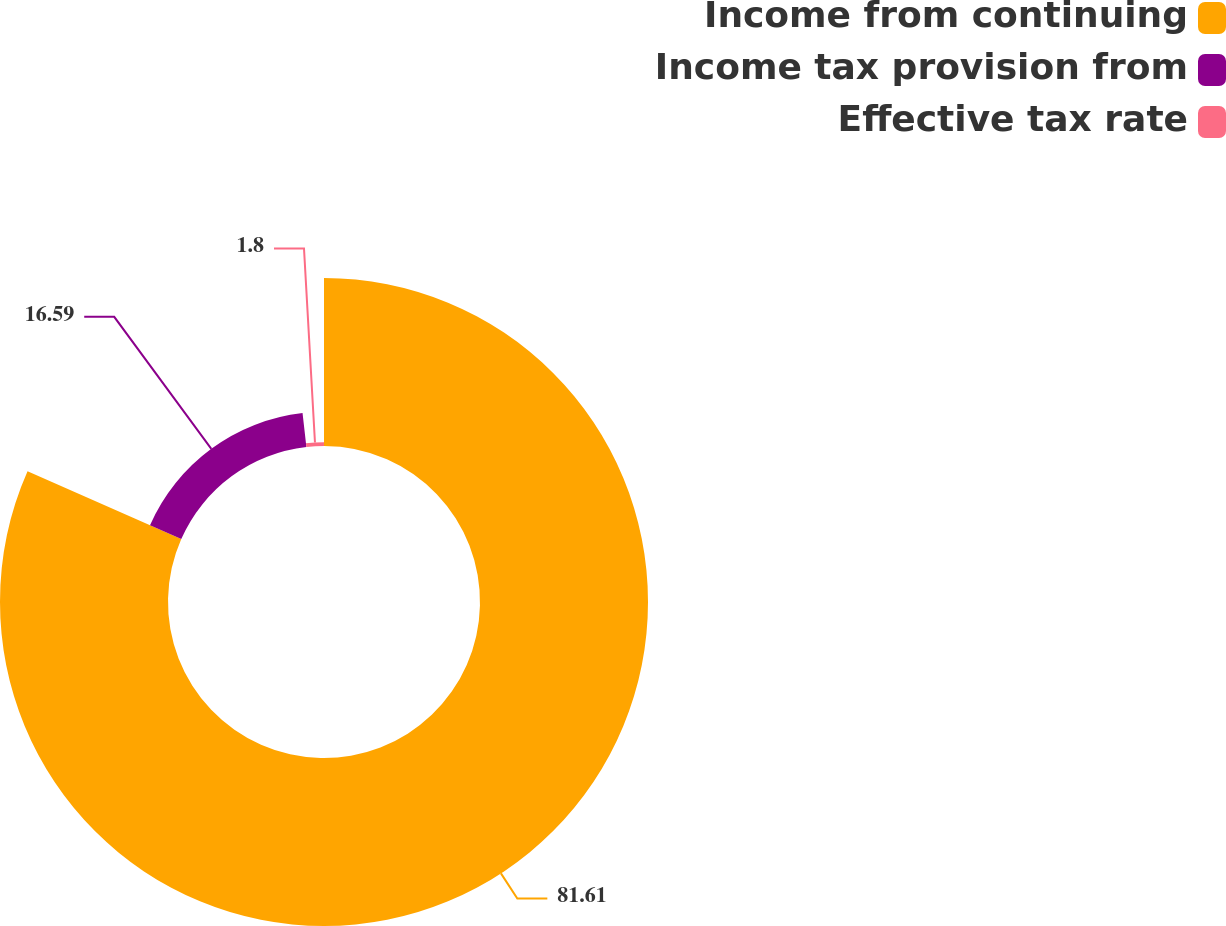Convert chart to OTSL. <chart><loc_0><loc_0><loc_500><loc_500><pie_chart><fcel>Income from continuing<fcel>Income tax provision from<fcel>Effective tax rate<nl><fcel>81.61%<fcel>16.59%<fcel>1.8%<nl></chart> 